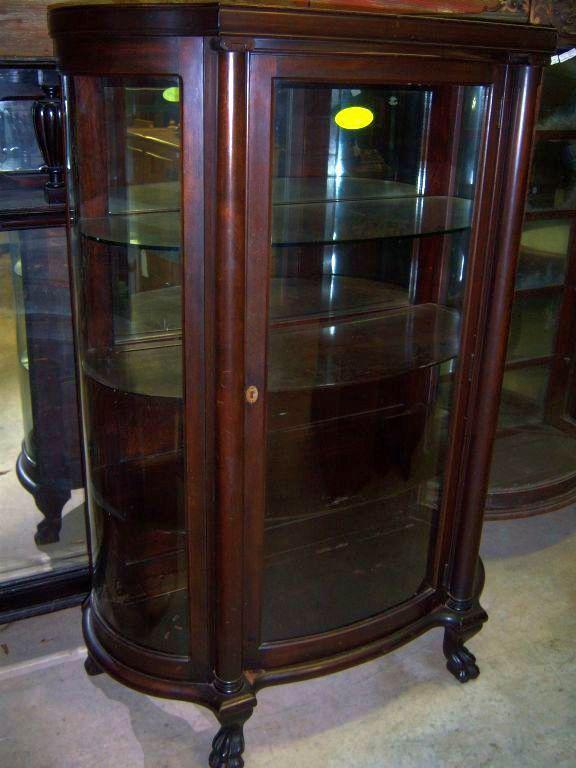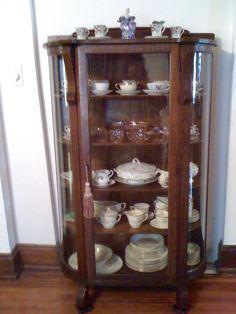The first image is the image on the left, the second image is the image on the right. Analyze the images presented: Is the assertion "There are two wood and glass cabinets, and they are both empty." valid? Answer yes or no. No. The first image is the image on the left, the second image is the image on the right. Considering the images on both sides, is "There are two empty wooden curio cabinets with glass fronts." valid? Answer yes or no. No. 